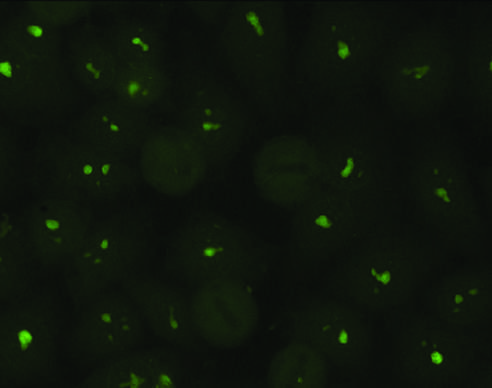s collagen typical of antibodies against nucleolar proteins?
Answer the question using a single word or phrase. No 